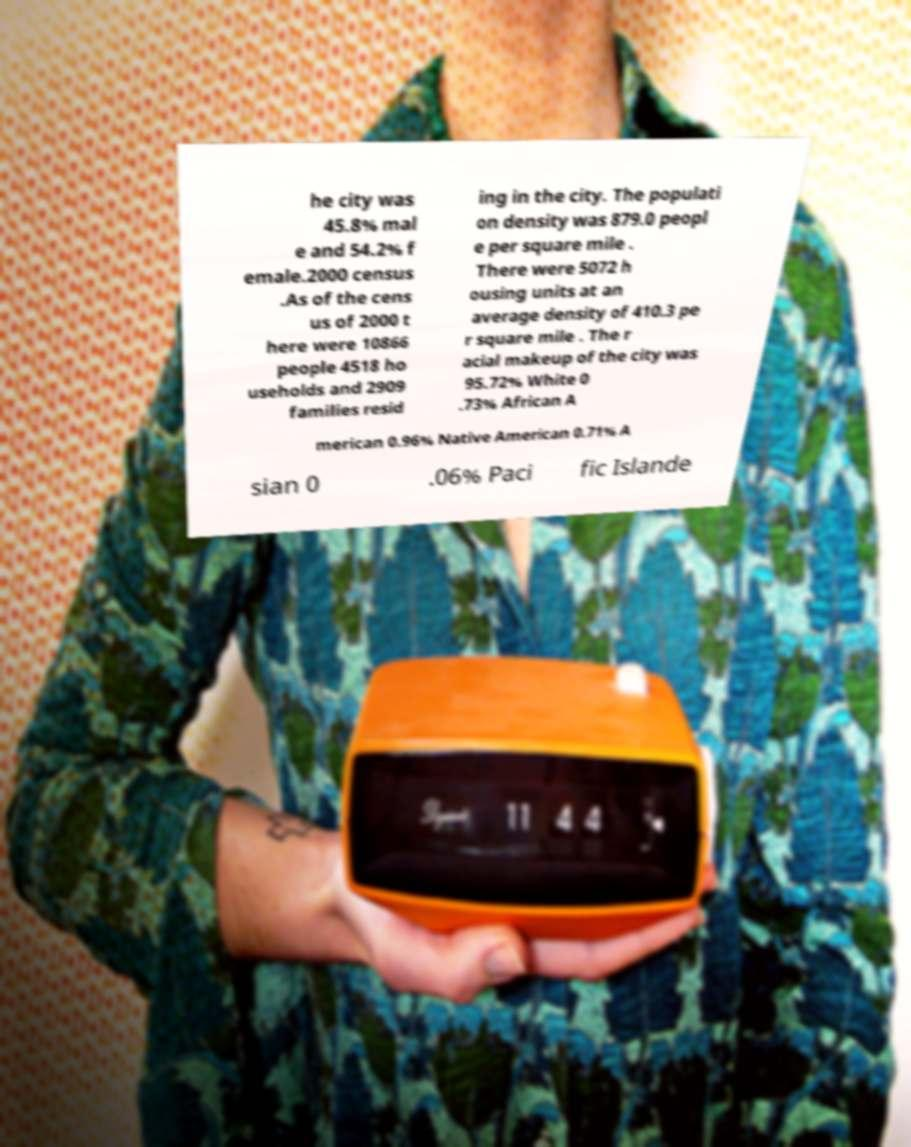Could you extract and type out the text from this image? he city was 45.8% mal e and 54.2% f emale.2000 census .As of the cens us of 2000 t here were 10866 people 4518 ho useholds and 2909 families resid ing in the city. The populati on density was 879.0 peopl e per square mile . There were 5072 h ousing units at an average density of 410.3 pe r square mile . The r acial makeup of the city was 95.72% White 0 .73% African A merican 0.96% Native American 0.71% A sian 0 .06% Paci fic Islande 